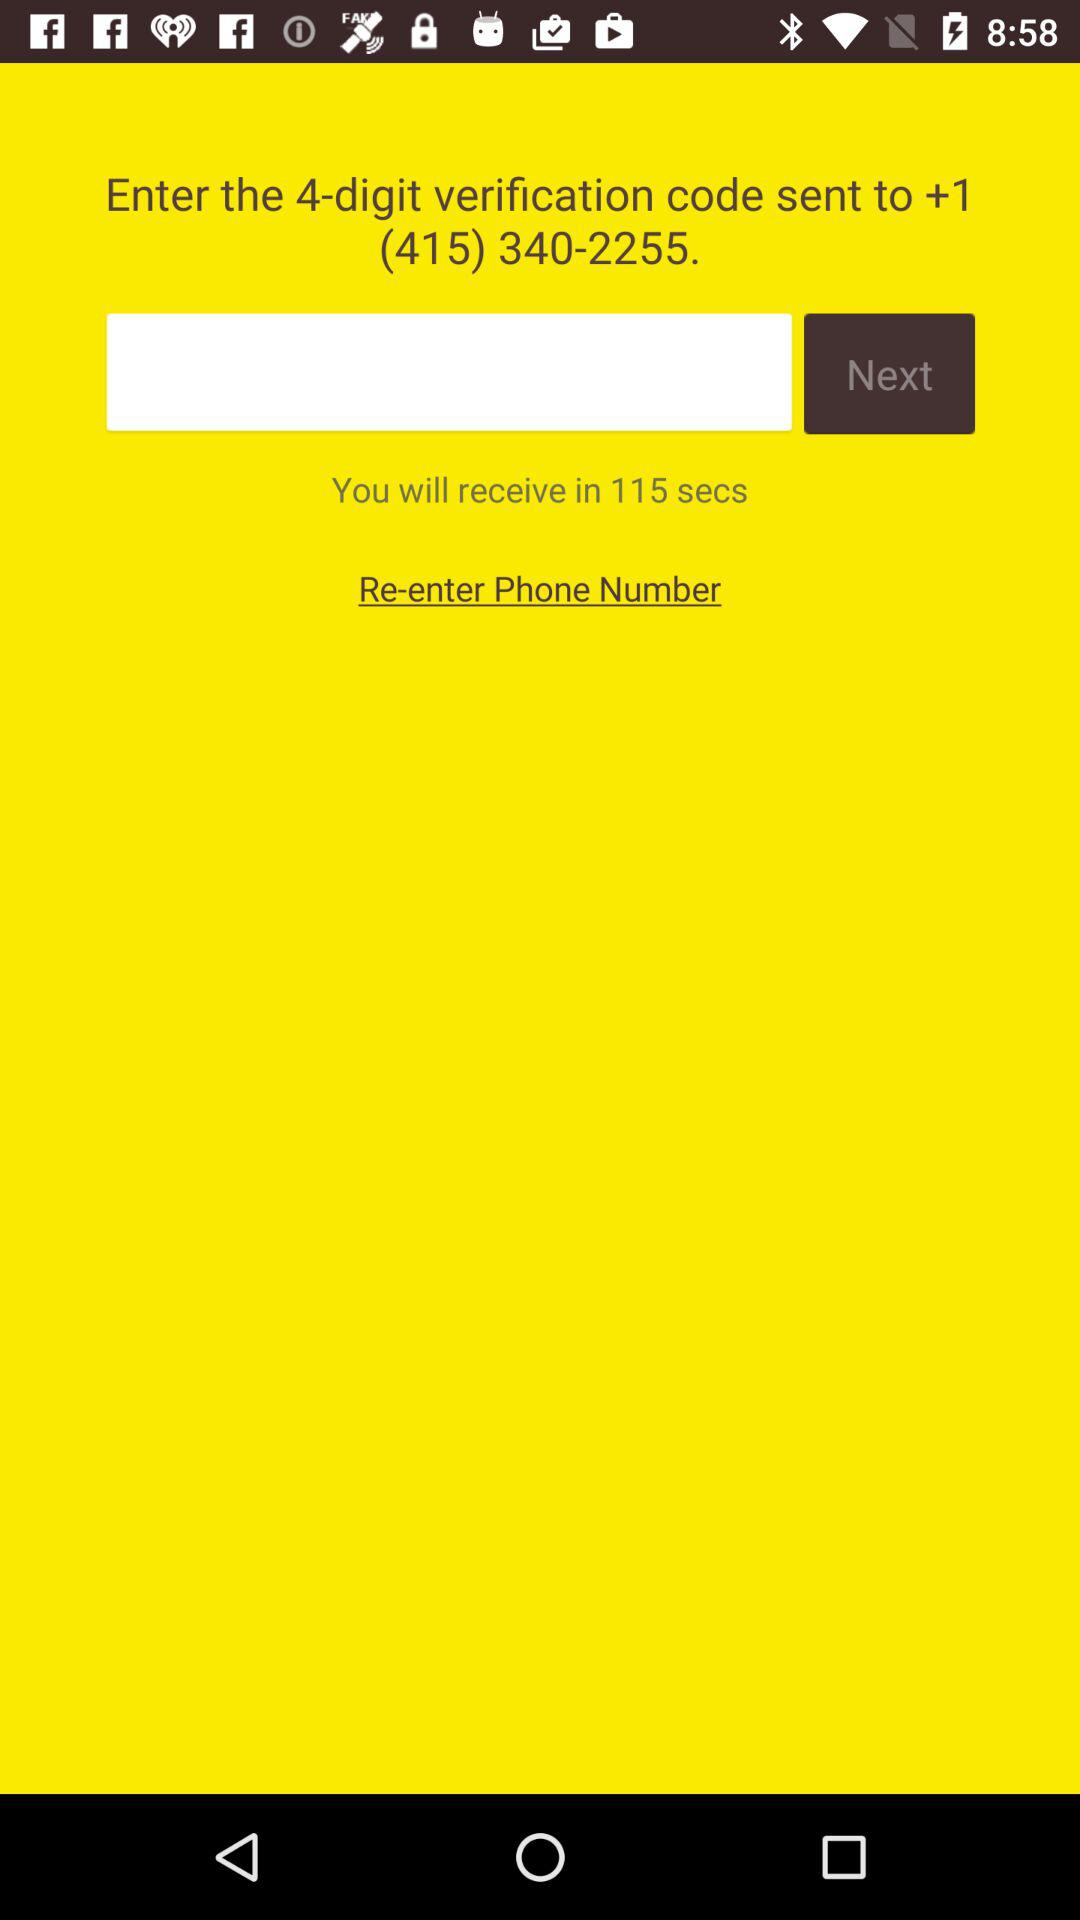What is the phone number? The phone number is +1 (415) 340-2255. 